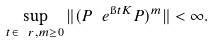Convert formula to latex. <formula><loc_0><loc_0><loc_500><loc_500>\sup _ { t \in \ r , m \geq 0 } \| ( P \ e ^ { \i t K } P ) ^ { m } \| < \infty .</formula> 